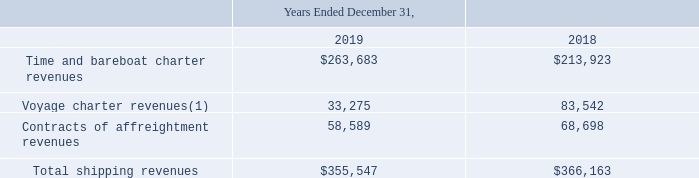Disaggregated Revenue
The Company has disaggregated revenue from contracts with customers into categories which depict how the nature, amount, timing and uncertainty of revenue and cash flows are affected by economic factors. Consequently, the disaggregation below is based on contract type.
Since the terms within these contract types are generally standard in nature, the Company does not believe that further disaggregation would result in increased insight into the economic factors impacting revenue and cash flows.
The following table shows the Company's shipping revenues disaggregated by nature of the charter arrangement for the years ended December 31, 2019 and 2018:
(1) Voyage charter revenues include approximately $10,152 and $7,600 of revenue related to short-term time charter contracts for the years ended December 31, 2019 and 2018, respectively.
Does the company believe that believe that further disaggregation would result in increased insight into the economic factors? The company does not believe that further disaggregation would result in increased insight into the economic factors impacting revenue and cash flows. What is the change in Time and bareboat charter revenues from Years Ended December 31, 2018 to 2019? 263,683-213,923
Answer: 49760. What is the average Time and bareboat charter revenues for Years Ended December 31, 2018 to 2019? (263,683+213,923) / 2
Answer: 238803. In which year was Voyage charter revenues less than 50,000? Locate and analyze voyage charter revenues(1) in row 4
answer: 2019. What was the Time and bareboat charter revenues revenues in 2019 and 2018 respectively? $263,683, $213,923. What was the Contracts of affreightment revenues in 2019 and 2018 respectively? 58,589, 68,698. 